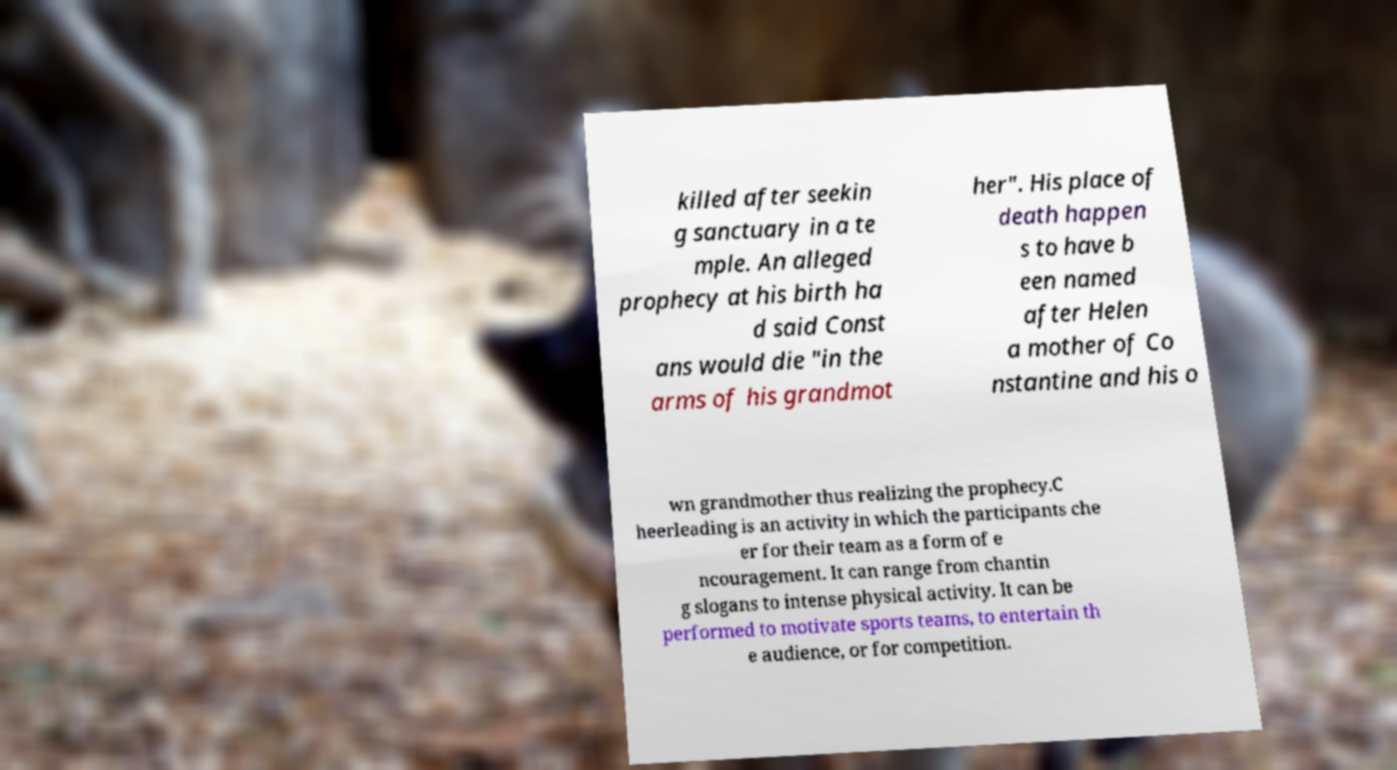For documentation purposes, I need the text within this image transcribed. Could you provide that? killed after seekin g sanctuary in a te mple. An alleged prophecy at his birth ha d said Const ans would die "in the arms of his grandmot her". His place of death happen s to have b een named after Helen a mother of Co nstantine and his o wn grandmother thus realizing the prophecy.C heerleading is an activity in which the participants che er for their team as a form of e ncouragement. It can range from chantin g slogans to intense physical activity. It can be performed to motivate sports teams, to entertain th e audience, or for competition. 